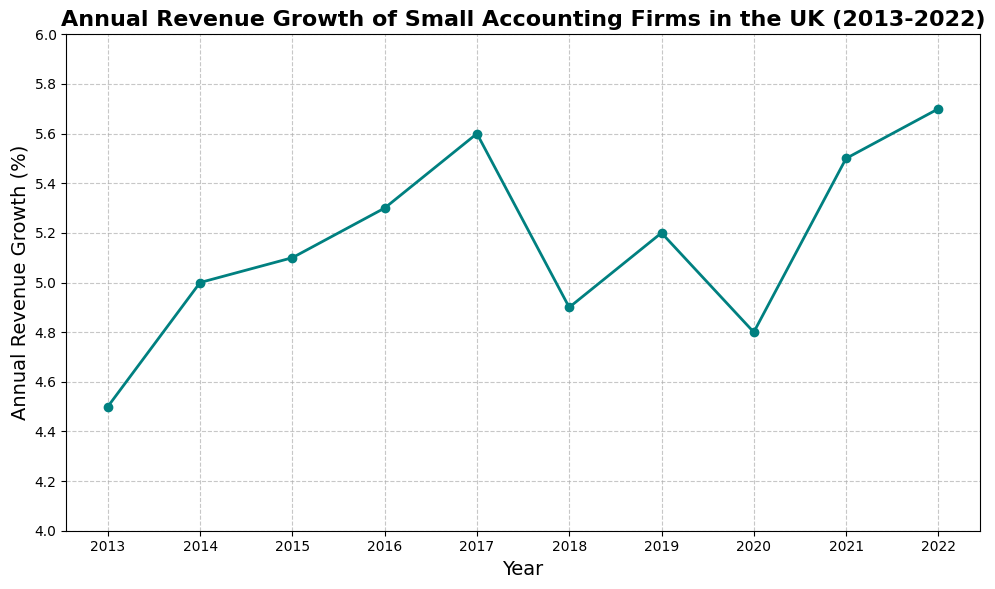How has the annual revenue growth rate changed from 2013 to 2022? To find the change, we look at the values for 2013 and 2022. The growth rate in 2013 is 4.5%, and in 2022 it is 5.7%. Subtracting the two, we get 5.7% - 4.5% = 1.2%.
Answer: The growth rate increased by 1.2% What was the highest annual revenue growth rate observed over the past decade? Reviewing the plot, the highest point in the graph corresponds to the year 2022 with an annual revenue growth rate of 5.7%.
Answer: 5.7% In which year(s) did the annual revenue growth rate decrease compared to the previous year? Observing the graph, the decrease occurs where the line slopes downward. The decreases are noted from 2017 to 2018 (5.6% to 4.9%) and from 2019 to 2020 (5.2% to 4.8%).
Answer: 2018, 2020 What is the average annual revenue growth rate over the decade? Adding up all the growth rates: 4.5 + 5.0 + 5.1 + 5.3 + 5.6 + 4.9 + 5.2 + 4.8 + 5.5 + 5.7 = 51.6%. Divide by the number of years (10): 51.6 / 10 = 5.16%.
Answer: 5.16% Compare the annual revenue growth rate in 2015 and 2021. Which year had a higher growth rate? Looking at the graph, in 2015 the growth rate was 5.1%, and in 2021 it was 5.5%. Thus, 2021 had a higher growth rate.
Answer: 2021 What’s the median annual revenue growth rate over the given period? To find the median, we list the growth rates in ascending order: 4.5, 4.8, 4.9, 5.0, 5.1, 5.2, 5.3, 5.5, 5.6, 5.7. The median (middle value in an ordered list) for 10 data points is the average of the 5th and 6th values: (5.1 + 5.2) / 2 = 5.15%.
Answer: 5.15% Which year had the smallest annual revenue growth rate? The lowest point in the graph corresponds to the year 2020 with a growth rate of 4.8%.
Answer: 2020 What trend can be observed in the annual revenue growth from 2013 to 2017? Observing the line graph from 2013 to 2017, there is a consistent upward trend, increasing from 4.5% to 5.6%.
Answer: Upward trend Is there a visible pattern or trend in the growth rates after 2017? After 2017, the growth rate decreases in 2018, then fluctuates with a decrease in 2020, followed by increases in 2021 and 2022.
Answer: Fluctuating with overall growth Calculate the total increase in the annual revenue growth rate from 2013 to 2017. To find the total increase from 2013 to 2017, subtract the growth rate in 2013 (4.5%) from the growth rate in 2017 (5.6%): 5.6% - 4.5% = 1.1%.
Answer: 1.1% 